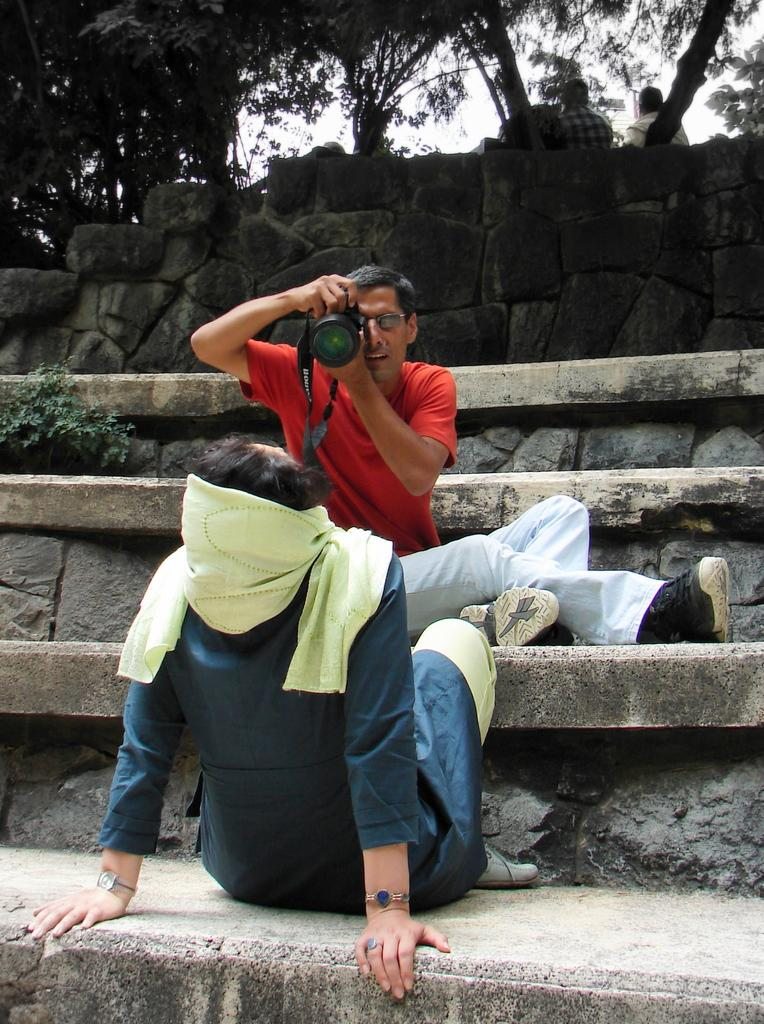What can be seen in the image that people use to move between different levels? There are stairs in the image that people use to move between different levels. How many people are sitting in the image? There are two people sitting in the image. What type of natural vegetation is visible in the image? There are trees in the image. What part of the natural environment is visible in the image? The sky is visible in the image. What is the man wearing in the image? The man is wearing a red color t-shirt. What is the man holding in the image? The man is holding a camera. What type of toys can be seen in the image? There are no toys present in the image. Can you describe the argument between the two people in the image? There is no argument between the two people in the image; they are simply sitting. What type of farm equipment is visible in the image? There is no farm equipment, such as a plough, present in the image. 